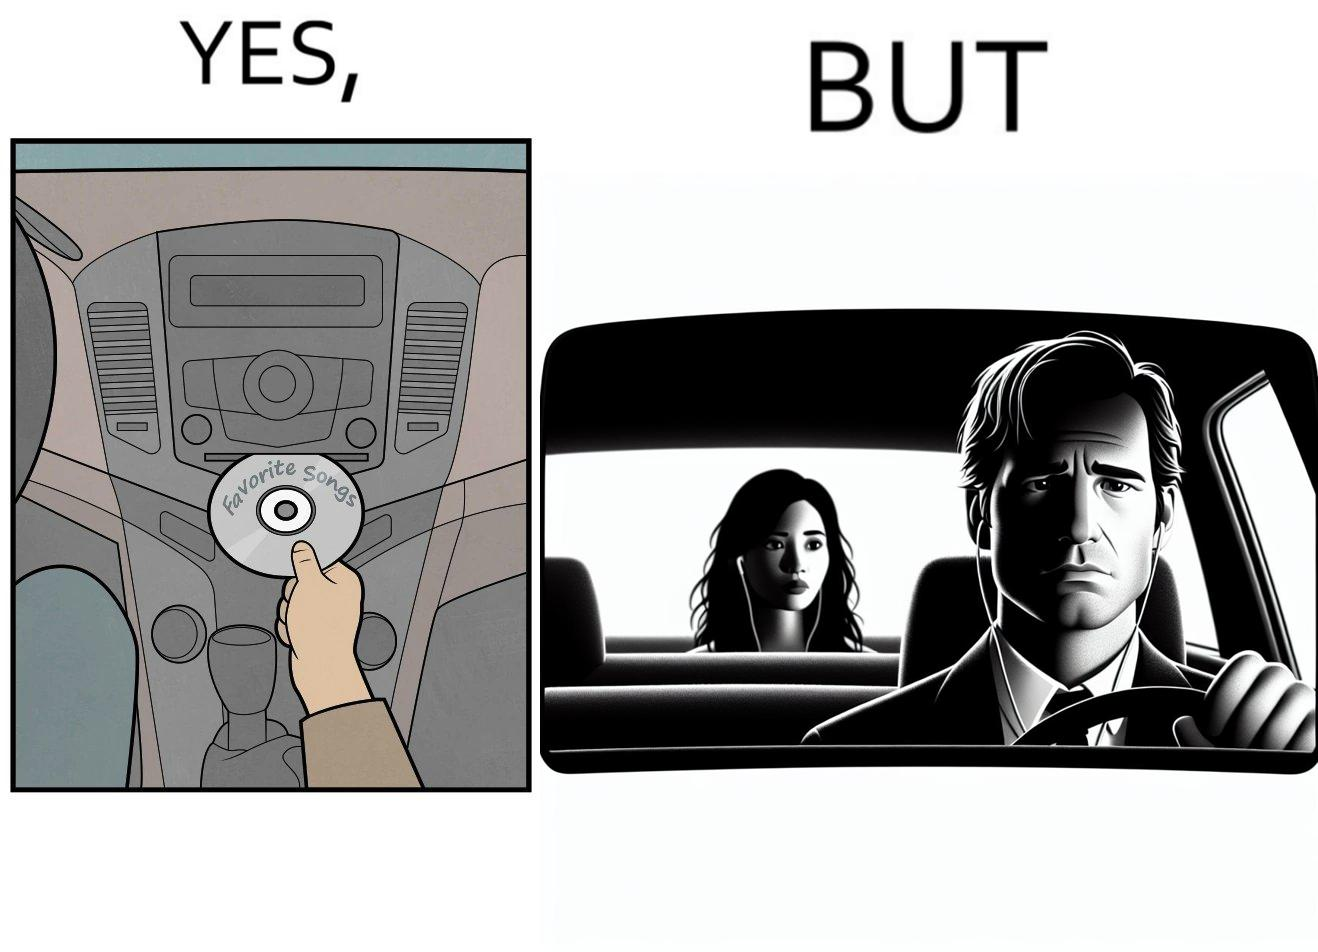Describe the satirical element in this image. The image is funny, as the driver of the car inserts a CD named "Favorite Songs" into the CD player for the passenger, but the driver is sad on seeing the passenger in the back seat listening to something else on earphones instead. 